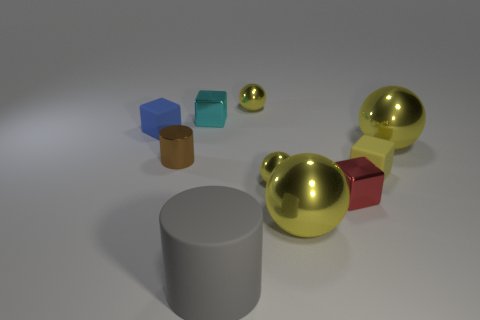Subtract all yellow blocks. How many blocks are left? 3 Subtract all gray cylinders. How many cylinders are left? 1 Subtract 1 blocks. How many blocks are left? 3 Subtract all cylinders. How many objects are left? 8 Subtract all green balls. How many yellow blocks are left? 1 Subtract 1 cyan blocks. How many objects are left? 9 Subtract all yellow cylinders. Subtract all gray spheres. How many cylinders are left? 2 Subtract all tiny yellow metal balls. Subtract all large metal things. How many objects are left? 6 Add 4 matte things. How many matte things are left? 7 Add 1 metal cylinders. How many metal cylinders exist? 2 